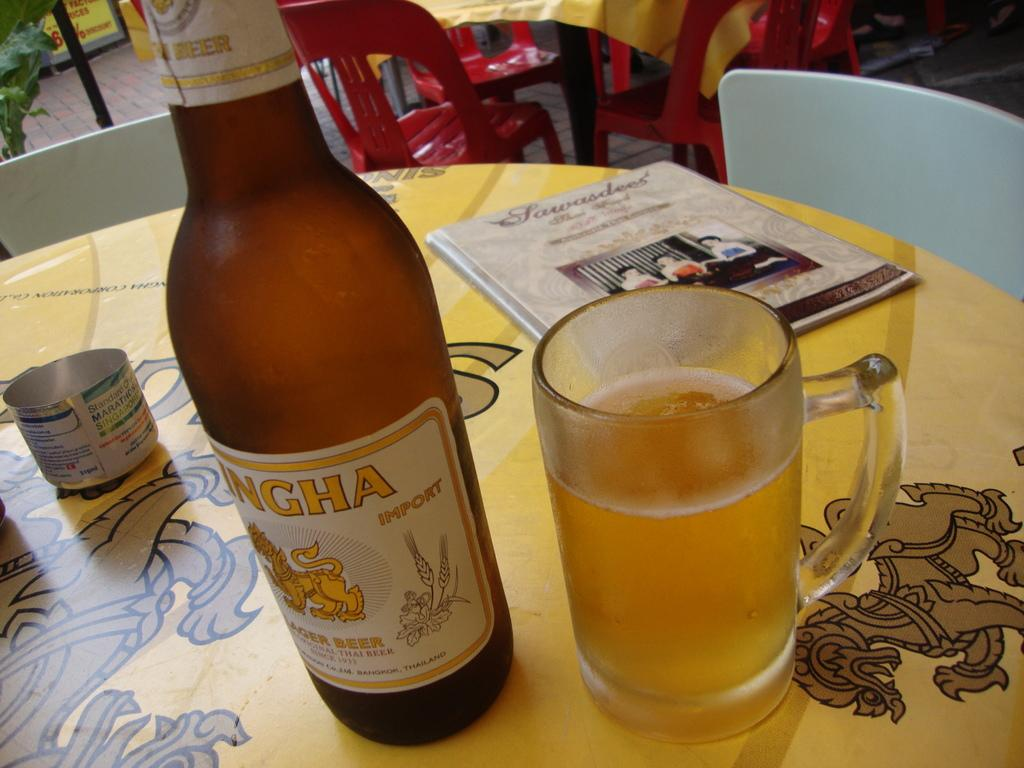<image>
Summarize the visual content of the image. A bottle of Ingha Lager Beers sits on a table embellished with chinese dragons 